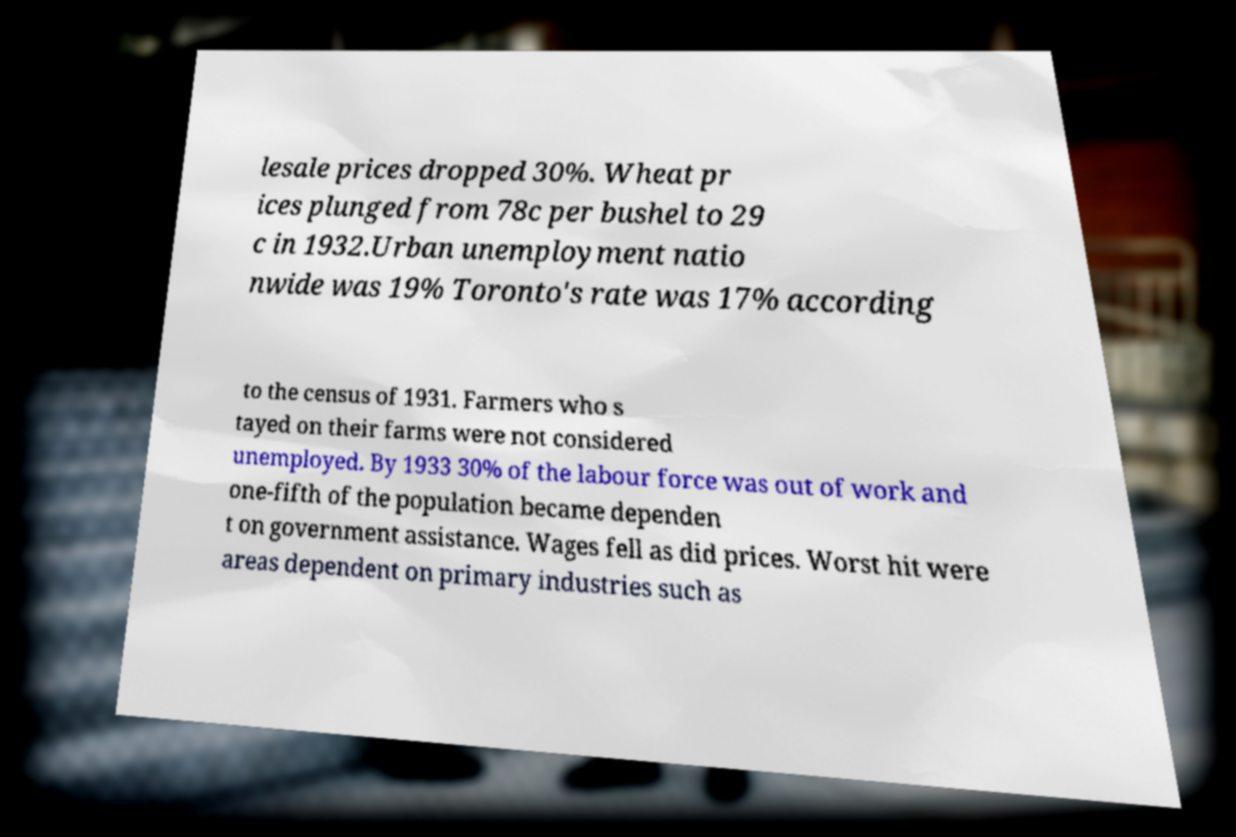Please identify and transcribe the text found in this image. lesale prices dropped 30%. Wheat pr ices plunged from 78c per bushel to 29 c in 1932.Urban unemployment natio nwide was 19% Toronto's rate was 17% according to the census of 1931. Farmers who s tayed on their farms were not considered unemployed. By 1933 30% of the labour force was out of work and one-fifth of the population became dependen t on government assistance. Wages fell as did prices. Worst hit were areas dependent on primary industries such as 